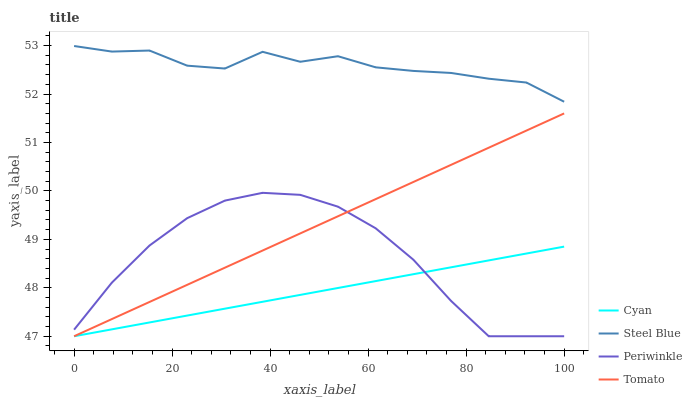Does Periwinkle have the minimum area under the curve?
Answer yes or no. No. Does Periwinkle have the maximum area under the curve?
Answer yes or no. No. Is Periwinkle the smoothest?
Answer yes or no. No. Is Periwinkle the roughest?
Answer yes or no. No. Does Steel Blue have the lowest value?
Answer yes or no. No. Does Periwinkle have the highest value?
Answer yes or no. No. Is Tomato less than Steel Blue?
Answer yes or no. Yes. Is Steel Blue greater than Periwinkle?
Answer yes or no. Yes. Does Tomato intersect Steel Blue?
Answer yes or no. No. 